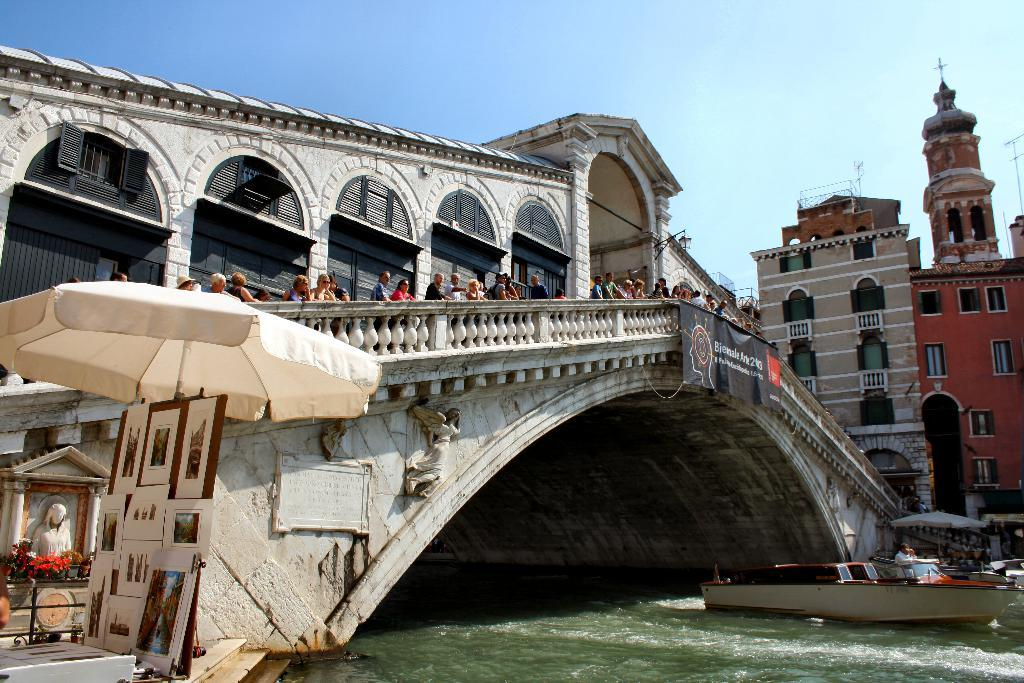What type of structures can be seen in the image? There are buildings in the image. What type of transportation is present in the image? There is a bridge and a boat in the image. What type of signage is present in the image? There is a banner in the image. What type of objects are present in the image? There are boards, pictures, umbrellas, and a statue in the image. Are there any living beings in the image? Yes, there are people in the image. What natural elements can be seen in the image? There is water and sky visible in the image. Are there any unspecified objects in the image? Yes, there are unspecified objects in the image. What is written on the banner? Something is written on the banner in the image. What type of cabbage is growing on the bridge in the image? There is no cabbage present in the image, and the bridge is not a place where plants typically grow. What type of seed is used to create the boat in the image? The boat in the image is not made of seeds; it is likely made of wood or another material. 